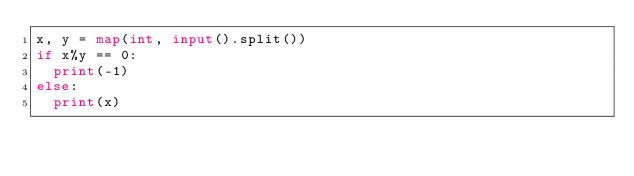Convert code to text. <code><loc_0><loc_0><loc_500><loc_500><_Python_>x, y = map(int, input().split())
if x%y == 0:
  print(-1)
else:
  print(x)</code> 